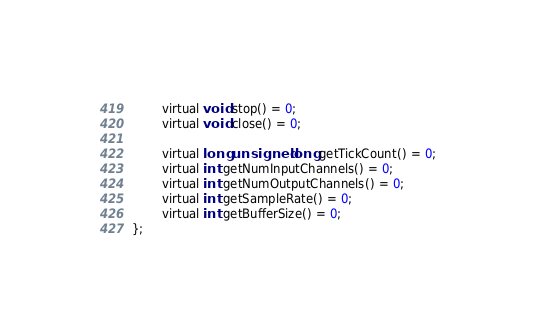Convert code to text. <code><loc_0><loc_0><loc_500><loc_500><_C_>		virtual void stop() = 0;
		virtual void close() = 0;

		virtual long unsigned long getTickCount() = 0;
		virtual int getNumInputChannels() = 0;
		virtual int getNumOutputChannels() = 0;
		virtual int getSampleRate() = 0;
		virtual int getBufferSize() = 0;
};
</code> 